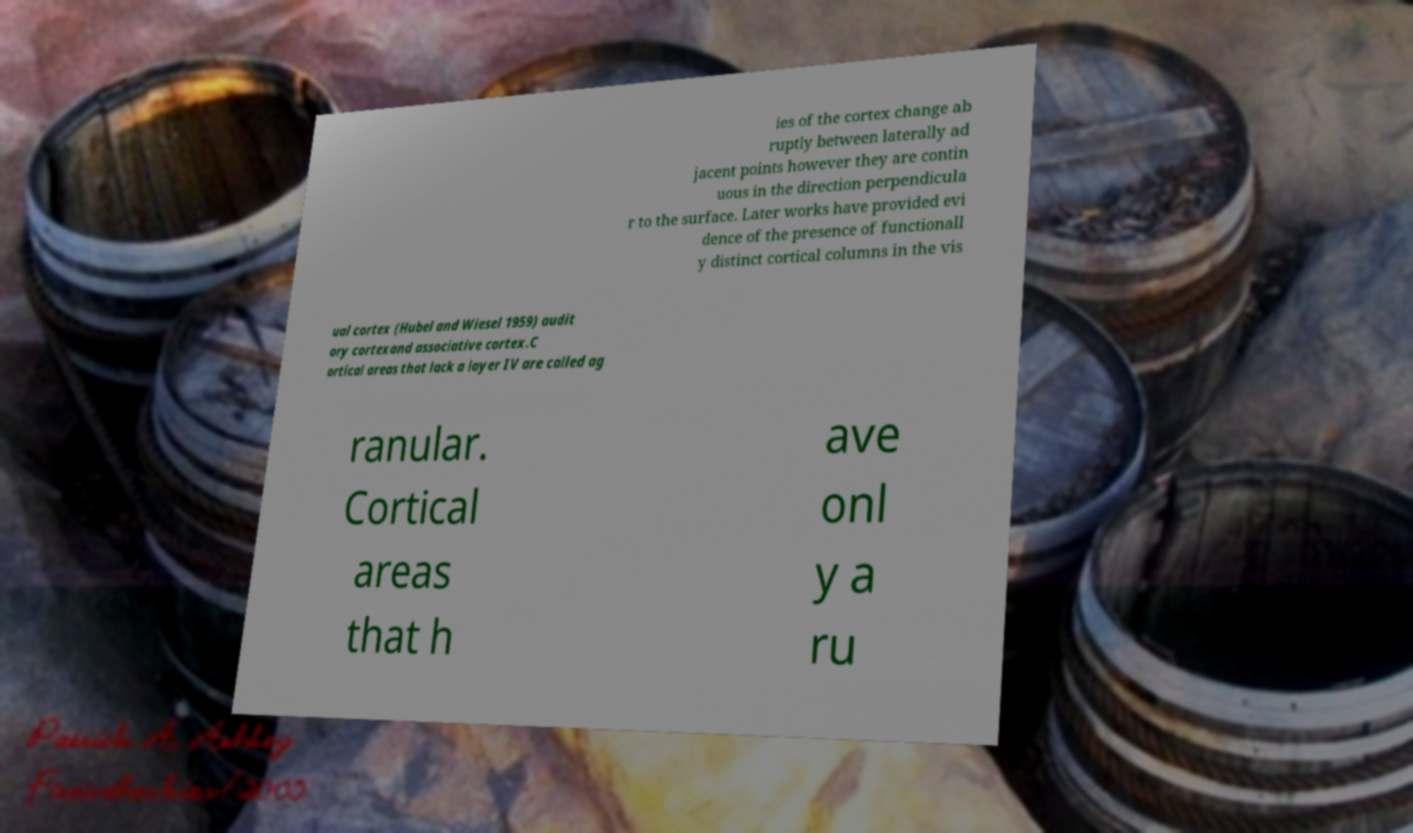What messages or text are displayed in this image? I need them in a readable, typed format. ies of the cortex change ab ruptly between laterally ad jacent points however they are contin uous in the direction perpendicula r to the surface. Later works have provided evi dence of the presence of functionall y distinct cortical columns in the vis ual cortex (Hubel and Wiesel 1959) audit ory cortexand associative cortex.C ortical areas that lack a layer IV are called ag ranular. Cortical areas that h ave onl y a ru 